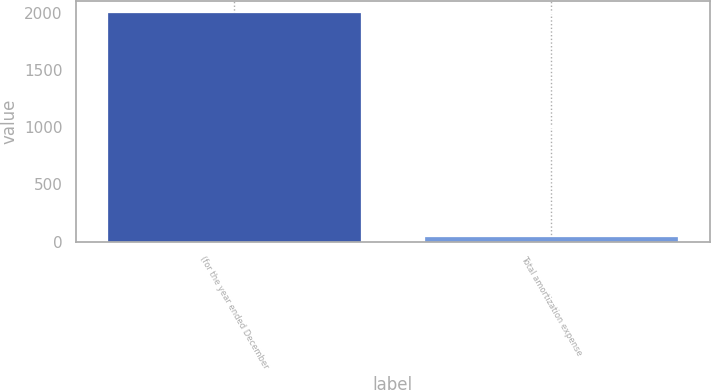Convert chart. <chart><loc_0><loc_0><loc_500><loc_500><bar_chart><fcel>(for the year ended December<fcel>Total amortization expense<nl><fcel>2003<fcel>42<nl></chart> 